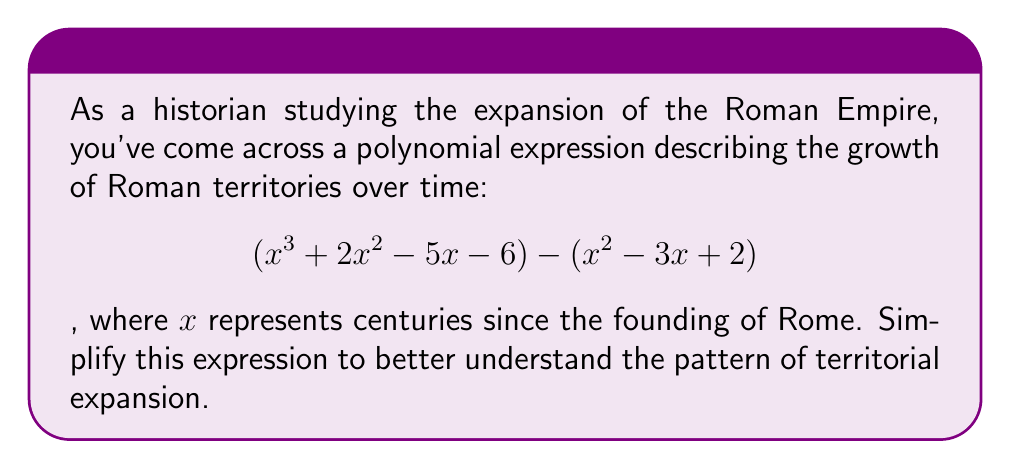Can you answer this question? To simplify this polynomial expression, we'll follow these steps:

1) First, let's identify the two polynomials:
   $P_1(x) = x^3 + 2x^2 - 5x - 6$
   $P_2(x) = x^2 - 3x + 2$

2) The expression is $P_1(x) - P_2(x)$, so we need to subtract $P_2(x)$ from $P_1(x)$.

3) When subtracting polynomials, we subtract the coefficients of like terms:

   $$(x^3 + 2x^2 - 5x - 6) - (x^2 - 3x + 2)$$
   
   $= x^3 + 2x^2 - 5x - 6 - x^2 + 3x - 2$

4) Now, let's combine like terms:
   
   $x^3$ term: No change, as there's only one.
   $x^2$ terms: $2x^2 - x^2 = x^2$
   $x$ terms: $-5x + 3x = -2x$
   Constant terms: $-6 - 2 = -8$

5) Writing our simplified polynomial:

   $$x^3 + x^2 - 2x - 8$$

This simplified expression represents the net growth of Roman territories over time, accounting for both expansion and potential losses.
Answer: $$x^3 + x^2 - 2x - 8$$ 